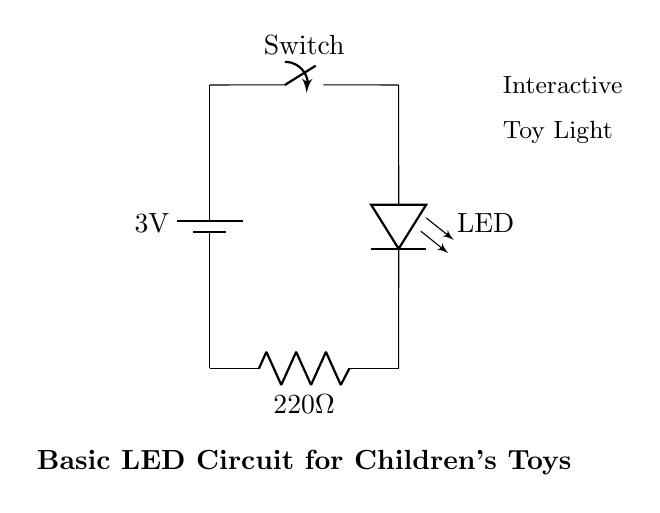What is the voltage of the battery? The voltage is 3 volts, indicated by the label next to the battery symbol in the diagram.
Answer: 3 volts What component is represented by the shape on the bottom right of the diagram? The component is a resistor, denoted by the standard symbol for a resistor and labeled with its resistance value of 220 ohms.
Answer: Resistor How many main components are in the circuit? There are four main components: a battery, a switch, an LED, and a resistor. Each component is clearly represented in the diagram.
Answer: Four What would happen if the switch is open? If the switch is open, the circuit is incomplete, and as a result, the LED will not light up. This is because current cannot flow through an open switch, stopping the flow to the LED.
Answer: LED will not light What is the purpose of the resistor in this circuit? The resistor limits the current flowing through the LED to prevent it from being damaged. LEDs typically require a specific current, and the resistor helps to maintain that level.
Answer: Current limiting Which way does current flow in this circuit? Current flows from the positive terminal of the battery, through the switch, LED, and resistor, returning to the negative terminal of the battery. This can be inferred from the connections that show the path of the circuit.
Answer: Positive to negative What is the function of the switch? The switch controls the flow of electricity in the circuit; when closed, it allows current to flow, and when open, it stops the current. This allows for easy turning on and off of the LED.
Answer: On/Off control 